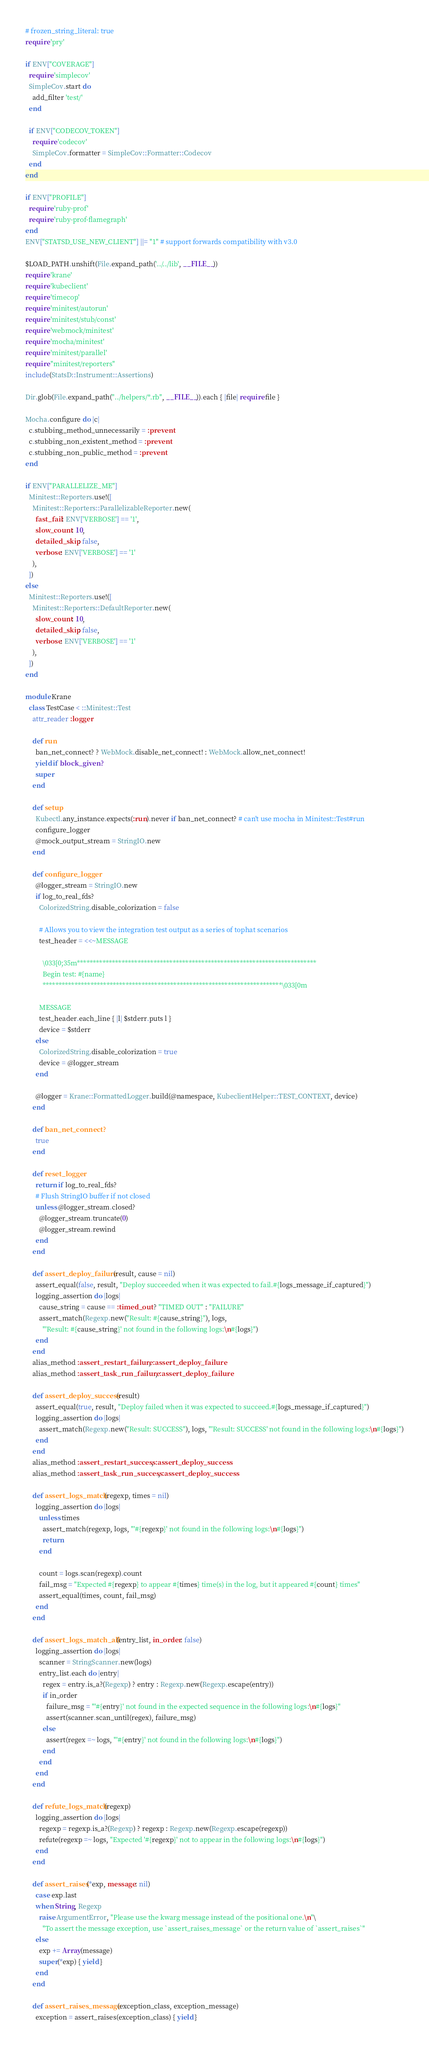Convert code to text. <code><loc_0><loc_0><loc_500><loc_500><_Ruby_># frozen_string_literal: true
require 'pry'

if ENV["COVERAGE"]
  require 'simplecov'
  SimpleCov.start do
    add_filter 'test/'
  end

  if ENV["CODECOV_TOKEN"]
    require 'codecov'
    SimpleCov.formatter = SimpleCov::Formatter::Codecov
  end
end

if ENV["PROFILE"]
  require 'ruby-prof'
  require 'ruby-prof-flamegraph'
end
ENV["STATSD_USE_NEW_CLIENT"] ||= "1" # support forwards compatibility with v3.0

$LOAD_PATH.unshift(File.expand_path('../../lib', __FILE__))
require 'krane'
require 'kubeclient'
require 'timecop'
require 'minitest/autorun'
require 'minitest/stub/const'
require 'webmock/minitest'
require 'mocha/minitest'
require 'minitest/parallel'
require "minitest/reporters"
include(StatsD::Instrument::Assertions)

Dir.glob(File.expand_path("../helpers/*.rb", __FILE__)).each { |file| require file }

Mocha.configure do |c|
  c.stubbing_method_unnecessarily = :prevent
  c.stubbing_non_existent_method = :prevent
  c.stubbing_non_public_method = :prevent
end

if ENV["PARALLELIZE_ME"]
  Minitest::Reporters.use!([
    Minitest::Reporters::ParallelizableReporter.new(
      fast_fail: ENV['VERBOSE'] == '1',
      slow_count: 10,
      detailed_skip: false,
      verbose: ENV['VERBOSE'] == '1'
    ),
  ])
else
  Minitest::Reporters.use!([
    Minitest::Reporters::DefaultReporter.new(
      slow_count: 10,
      detailed_skip: false,
      verbose: ENV['VERBOSE'] == '1'
    ),
  ])
end

module Krane
  class TestCase < ::Minitest::Test
    attr_reader :logger

    def run
      ban_net_connect? ? WebMock.disable_net_connect! : WebMock.allow_net_connect!
      yield if block_given?
      super
    end

    def setup
      Kubectl.any_instance.expects(:run).never if ban_net_connect? # can't use mocha in Minitest::Test#run
      configure_logger
      @mock_output_stream = StringIO.new
    end

    def configure_logger
      @logger_stream = StringIO.new
      if log_to_real_fds?
        ColorizedString.disable_colorization = false

        # Allows you to view the integration test output as a series of tophat scenarios
        test_header = <<~MESSAGE

          \033[0;35m***************************************************************************
          Begin test: #{name}
          ***************************************************************************\033[0m

        MESSAGE
        test_header.each_line { |l| $stderr.puts l }
        device = $stderr
      else
        ColorizedString.disable_colorization = true
        device = @logger_stream
      end

      @logger = Krane::FormattedLogger.build(@namespace, KubeclientHelper::TEST_CONTEXT, device)
    end

    def ban_net_connect?
      true
    end

    def reset_logger
      return if log_to_real_fds?
      # Flush StringIO buffer if not closed
      unless @logger_stream.closed?
        @logger_stream.truncate(0)
        @logger_stream.rewind
      end
    end

    def assert_deploy_failure(result, cause = nil)
      assert_equal(false, result, "Deploy succeeded when it was expected to fail.#{logs_message_if_captured}")
      logging_assertion do |logs|
        cause_string = cause == :timed_out ? "TIMED OUT" : "FAILURE"
        assert_match(Regexp.new("Result: #{cause_string}"), logs,
          "'Result: #{cause_string}' not found in the following logs:\n#{logs}")
      end
    end
    alias_method :assert_restart_failure, :assert_deploy_failure
    alias_method :assert_task_run_failure, :assert_deploy_failure

    def assert_deploy_success(result)
      assert_equal(true, result, "Deploy failed when it was expected to succeed.#{logs_message_if_captured}")
      logging_assertion do |logs|
        assert_match(Regexp.new("Result: SUCCESS"), logs, "'Result: SUCCESS' not found in the following logs:\n#{logs}")
      end
    end
    alias_method :assert_restart_success, :assert_deploy_success
    alias_method :assert_task_run_success, :assert_deploy_success

    def assert_logs_match(regexp, times = nil)
      logging_assertion do |logs|
        unless times
          assert_match(regexp, logs, "'#{regexp}' not found in the following logs:\n#{logs}")
          return
        end

        count = logs.scan(regexp).count
        fail_msg = "Expected #{regexp} to appear #{times} time(s) in the log, but it appeared #{count} times"
        assert_equal(times, count, fail_msg)
      end
    end

    def assert_logs_match_all(entry_list, in_order: false)
      logging_assertion do |logs|
        scanner = StringScanner.new(logs)
        entry_list.each do |entry|
          regex = entry.is_a?(Regexp) ? entry : Regexp.new(Regexp.escape(entry))
          if in_order
            failure_msg = "'#{entry}' not found in the expected sequence in the following logs:\n#{logs}"
            assert(scanner.scan_until(regex), failure_msg)
          else
            assert(regex =~ logs, "'#{entry}' not found in the following logs:\n#{logs}")
          end
        end
      end
    end

    def refute_logs_match(regexp)
      logging_assertion do |logs|
        regexp = regexp.is_a?(Regexp) ? regexp : Regexp.new(Regexp.escape(regexp))
        refute(regexp =~ logs, "Expected '#{regexp}' not to appear in the following logs:\n#{logs}")
      end
    end

    def assert_raises(*exp, message: nil)
      case exp.last
      when String, Regexp
        raise ArgumentError, "Please use the kwarg message instead of the positional one.\n"\
          "To assert the message exception, use `assert_raises_message` or the return value of `assert_raises`"
      else
        exp += Array(message)
        super(*exp) { yield }
      end
    end

    def assert_raises_message(exception_class, exception_message)
      exception = assert_raises(exception_class) { yield }</code> 